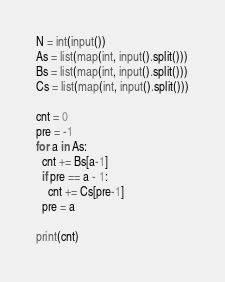<code> <loc_0><loc_0><loc_500><loc_500><_Python_>N = int(input())
As = list(map(int, input().split()))
Bs = list(map(int, input().split()))
Cs = list(map(int, input().split()))

cnt = 0
pre = -1
for a in As:
  cnt += Bs[a-1]
  if pre == a - 1:
    cnt += Cs[pre-1]
  pre = a
  
print(cnt)</code> 